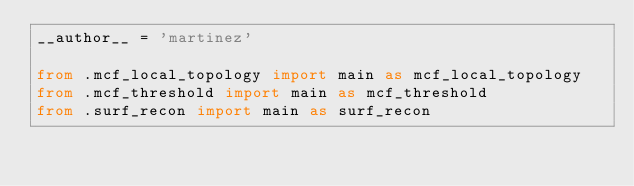Convert code to text. <code><loc_0><loc_0><loc_500><loc_500><_Python_>__author__ = 'martinez'

from .mcf_local_topology import main as mcf_local_topology
from .mcf_threshold import main as mcf_threshold
from .surf_recon import main as surf_recon</code> 